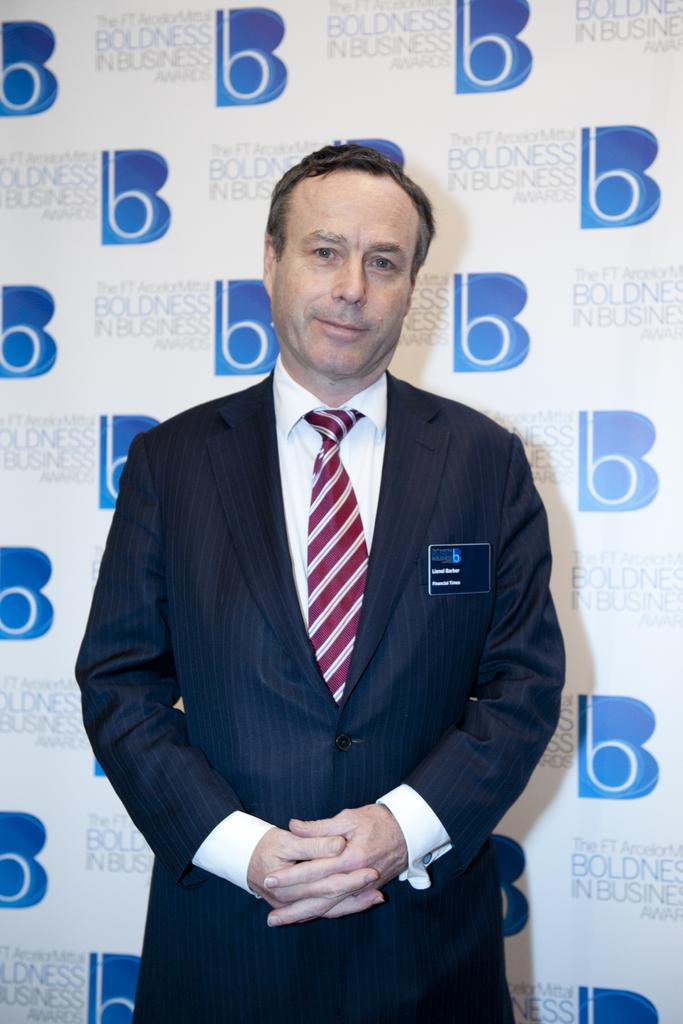What is the main subject of the image? The main subject of the image is a man standing. Can you describe any specific details about the man? Yes, the man has a card on his jacket. What is visible in the background behind the man? There is a banner with text behind the man. What type of insect can be seen crawling on the lamp in the image? There is no lamp or insect present in the image. How does the man's hearing affect the text on the banner in the image? The man's hearing does not affect the text on the banner in the image, as the text is stationary and not dependent on the man's hearing abilities. 